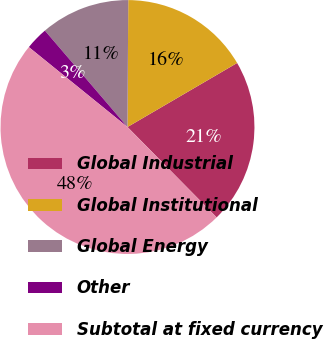Convert chart. <chart><loc_0><loc_0><loc_500><loc_500><pie_chart><fcel>Global Industrial<fcel>Global Institutional<fcel>Global Energy<fcel>Other<fcel>Subtotal at fixed currency<nl><fcel>21.02%<fcel>16.49%<fcel>11.37%<fcel>2.89%<fcel>48.23%<nl></chart> 